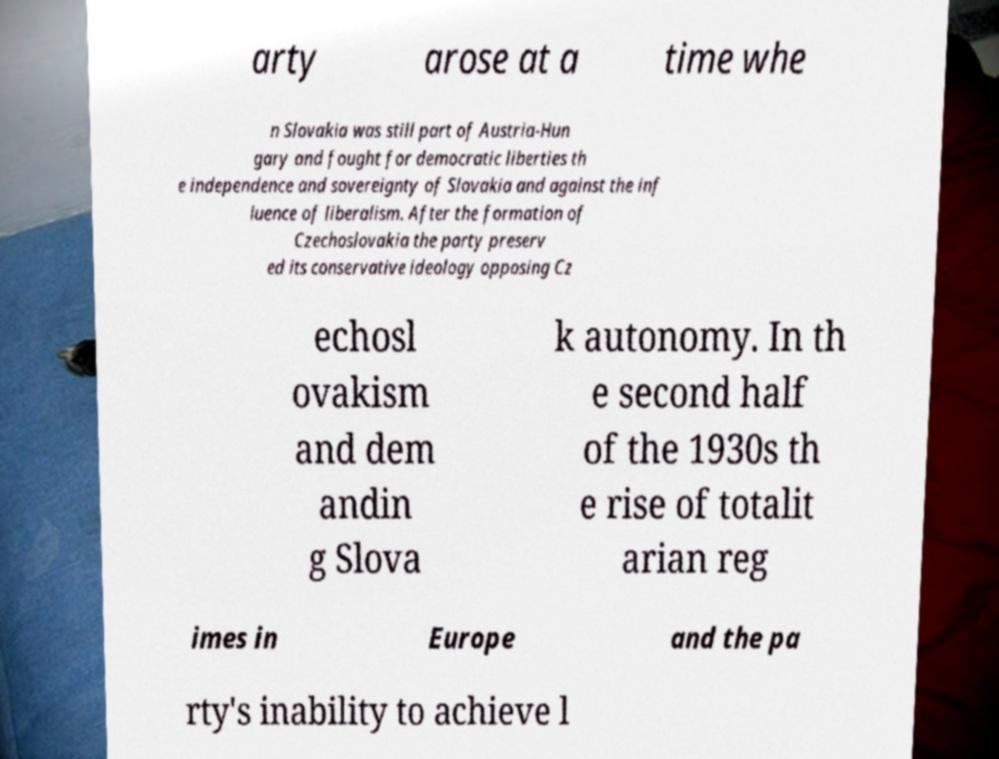What messages or text are displayed in this image? I need them in a readable, typed format. arty arose at a time whe n Slovakia was still part of Austria-Hun gary and fought for democratic liberties th e independence and sovereignty of Slovakia and against the inf luence of liberalism. After the formation of Czechoslovakia the party preserv ed its conservative ideology opposing Cz echosl ovakism and dem andin g Slova k autonomy. In th e second half of the 1930s th e rise of totalit arian reg imes in Europe and the pa rty's inability to achieve l 